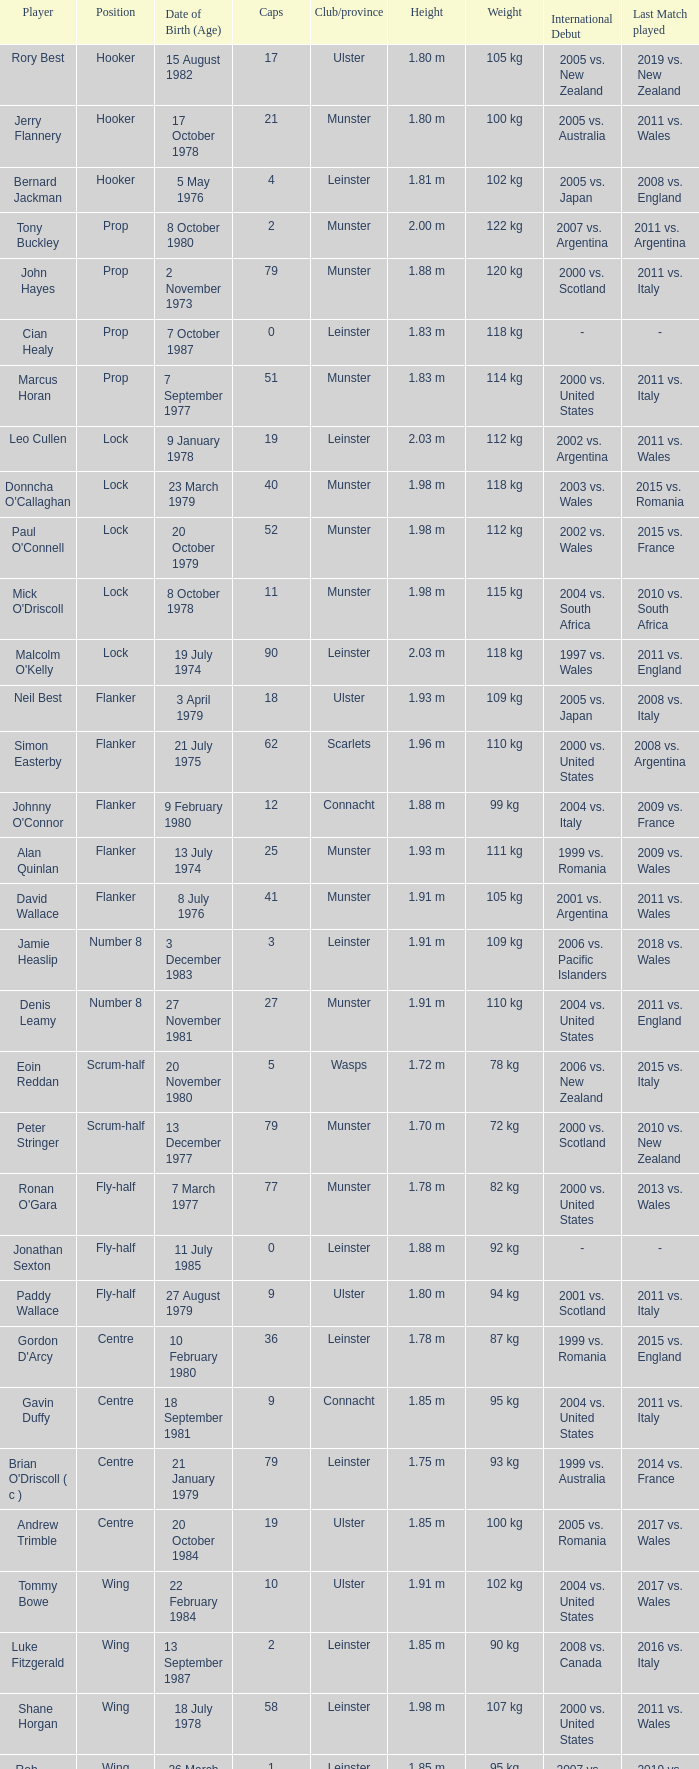What Club/province have caps less than 2 and Jonathan Sexton as player? Leinster. 